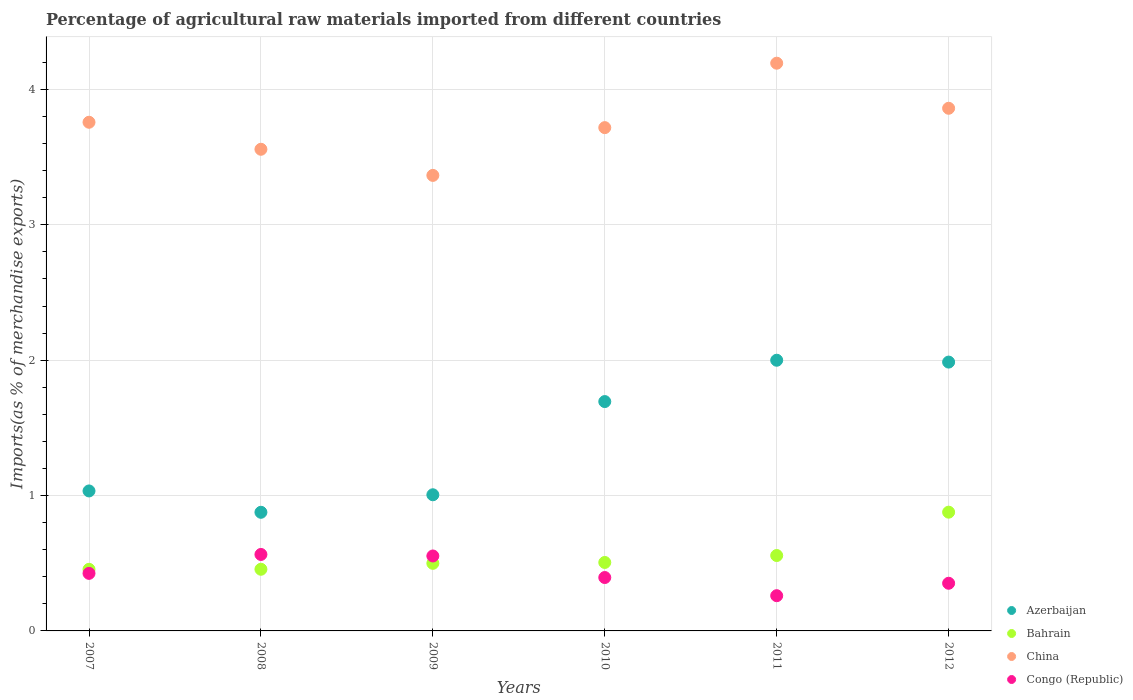What is the percentage of imports to different countries in China in 2007?
Offer a very short reply. 3.76. Across all years, what is the maximum percentage of imports to different countries in China?
Keep it short and to the point. 4.19. Across all years, what is the minimum percentage of imports to different countries in Congo (Republic)?
Your response must be concise. 0.26. What is the total percentage of imports to different countries in China in the graph?
Offer a terse response. 22.45. What is the difference between the percentage of imports to different countries in China in 2008 and that in 2012?
Provide a short and direct response. -0.3. What is the difference between the percentage of imports to different countries in China in 2007 and the percentage of imports to different countries in Congo (Republic) in 2012?
Ensure brevity in your answer.  3.41. What is the average percentage of imports to different countries in Bahrain per year?
Offer a terse response. 0.56. In the year 2012, what is the difference between the percentage of imports to different countries in Azerbaijan and percentage of imports to different countries in Congo (Republic)?
Offer a very short reply. 1.63. In how many years, is the percentage of imports to different countries in China greater than 0.4 %?
Your answer should be compact. 6. What is the ratio of the percentage of imports to different countries in Azerbaijan in 2011 to that in 2012?
Ensure brevity in your answer.  1.01. Is the percentage of imports to different countries in Bahrain in 2010 less than that in 2012?
Offer a very short reply. Yes. What is the difference between the highest and the second highest percentage of imports to different countries in Bahrain?
Offer a very short reply. 0.32. What is the difference between the highest and the lowest percentage of imports to different countries in Congo (Republic)?
Give a very brief answer. 0.3. In how many years, is the percentage of imports to different countries in Azerbaijan greater than the average percentage of imports to different countries in Azerbaijan taken over all years?
Give a very brief answer. 3. Is the sum of the percentage of imports to different countries in Congo (Republic) in 2008 and 2010 greater than the maximum percentage of imports to different countries in Bahrain across all years?
Your answer should be very brief. Yes. Is it the case that in every year, the sum of the percentage of imports to different countries in Azerbaijan and percentage of imports to different countries in Bahrain  is greater than the sum of percentage of imports to different countries in Congo (Republic) and percentage of imports to different countries in China?
Provide a succinct answer. Yes. What is the difference between two consecutive major ticks on the Y-axis?
Provide a short and direct response. 1. How are the legend labels stacked?
Provide a succinct answer. Vertical. What is the title of the graph?
Offer a very short reply. Percentage of agricultural raw materials imported from different countries. Does "Niger" appear as one of the legend labels in the graph?
Keep it short and to the point. No. What is the label or title of the X-axis?
Your answer should be very brief. Years. What is the label or title of the Y-axis?
Your answer should be compact. Imports(as % of merchandise exports). What is the Imports(as % of merchandise exports) in Azerbaijan in 2007?
Your answer should be very brief. 1.03. What is the Imports(as % of merchandise exports) in Bahrain in 2007?
Your response must be concise. 0.46. What is the Imports(as % of merchandise exports) of China in 2007?
Your answer should be very brief. 3.76. What is the Imports(as % of merchandise exports) of Congo (Republic) in 2007?
Your response must be concise. 0.43. What is the Imports(as % of merchandise exports) in Azerbaijan in 2008?
Ensure brevity in your answer.  0.88. What is the Imports(as % of merchandise exports) of Bahrain in 2008?
Keep it short and to the point. 0.46. What is the Imports(as % of merchandise exports) in China in 2008?
Give a very brief answer. 3.56. What is the Imports(as % of merchandise exports) of Congo (Republic) in 2008?
Give a very brief answer. 0.56. What is the Imports(as % of merchandise exports) of Azerbaijan in 2009?
Provide a succinct answer. 1.01. What is the Imports(as % of merchandise exports) of Bahrain in 2009?
Keep it short and to the point. 0.5. What is the Imports(as % of merchandise exports) in China in 2009?
Give a very brief answer. 3.37. What is the Imports(as % of merchandise exports) of Congo (Republic) in 2009?
Your answer should be very brief. 0.55. What is the Imports(as % of merchandise exports) of Azerbaijan in 2010?
Provide a short and direct response. 1.69. What is the Imports(as % of merchandise exports) in Bahrain in 2010?
Provide a short and direct response. 0.51. What is the Imports(as % of merchandise exports) of China in 2010?
Your response must be concise. 3.72. What is the Imports(as % of merchandise exports) of Congo (Republic) in 2010?
Your answer should be very brief. 0.39. What is the Imports(as % of merchandise exports) of Azerbaijan in 2011?
Keep it short and to the point. 2. What is the Imports(as % of merchandise exports) in Bahrain in 2011?
Make the answer very short. 0.56. What is the Imports(as % of merchandise exports) of China in 2011?
Offer a terse response. 4.19. What is the Imports(as % of merchandise exports) of Congo (Republic) in 2011?
Offer a very short reply. 0.26. What is the Imports(as % of merchandise exports) of Azerbaijan in 2012?
Provide a succinct answer. 1.99. What is the Imports(as % of merchandise exports) in Bahrain in 2012?
Your answer should be compact. 0.88. What is the Imports(as % of merchandise exports) in China in 2012?
Ensure brevity in your answer.  3.86. What is the Imports(as % of merchandise exports) of Congo (Republic) in 2012?
Offer a terse response. 0.35. Across all years, what is the maximum Imports(as % of merchandise exports) in Azerbaijan?
Offer a terse response. 2. Across all years, what is the maximum Imports(as % of merchandise exports) of Bahrain?
Provide a short and direct response. 0.88. Across all years, what is the maximum Imports(as % of merchandise exports) in China?
Keep it short and to the point. 4.19. Across all years, what is the maximum Imports(as % of merchandise exports) in Congo (Republic)?
Make the answer very short. 0.56. Across all years, what is the minimum Imports(as % of merchandise exports) of Azerbaijan?
Offer a very short reply. 0.88. Across all years, what is the minimum Imports(as % of merchandise exports) of Bahrain?
Give a very brief answer. 0.46. Across all years, what is the minimum Imports(as % of merchandise exports) of China?
Your answer should be very brief. 3.37. Across all years, what is the minimum Imports(as % of merchandise exports) in Congo (Republic)?
Provide a succinct answer. 0.26. What is the total Imports(as % of merchandise exports) of Azerbaijan in the graph?
Give a very brief answer. 8.6. What is the total Imports(as % of merchandise exports) of Bahrain in the graph?
Offer a very short reply. 3.35. What is the total Imports(as % of merchandise exports) in China in the graph?
Provide a succinct answer. 22.45. What is the total Imports(as % of merchandise exports) of Congo (Republic) in the graph?
Your answer should be compact. 2.55. What is the difference between the Imports(as % of merchandise exports) of Azerbaijan in 2007 and that in 2008?
Offer a very short reply. 0.16. What is the difference between the Imports(as % of merchandise exports) in Bahrain in 2007 and that in 2008?
Provide a short and direct response. -0. What is the difference between the Imports(as % of merchandise exports) in China in 2007 and that in 2008?
Provide a succinct answer. 0.2. What is the difference between the Imports(as % of merchandise exports) in Congo (Republic) in 2007 and that in 2008?
Offer a very short reply. -0.14. What is the difference between the Imports(as % of merchandise exports) in Azerbaijan in 2007 and that in 2009?
Your answer should be very brief. 0.03. What is the difference between the Imports(as % of merchandise exports) of Bahrain in 2007 and that in 2009?
Ensure brevity in your answer.  -0.04. What is the difference between the Imports(as % of merchandise exports) of China in 2007 and that in 2009?
Provide a short and direct response. 0.39. What is the difference between the Imports(as % of merchandise exports) of Congo (Republic) in 2007 and that in 2009?
Keep it short and to the point. -0.13. What is the difference between the Imports(as % of merchandise exports) in Azerbaijan in 2007 and that in 2010?
Keep it short and to the point. -0.66. What is the difference between the Imports(as % of merchandise exports) in Bahrain in 2007 and that in 2010?
Your answer should be very brief. -0.05. What is the difference between the Imports(as % of merchandise exports) of China in 2007 and that in 2010?
Offer a very short reply. 0.04. What is the difference between the Imports(as % of merchandise exports) of Congo (Republic) in 2007 and that in 2010?
Your response must be concise. 0.03. What is the difference between the Imports(as % of merchandise exports) of Azerbaijan in 2007 and that in 2011?
Give a very brief answer. -0.97. What is the difference between the Imports(as % of merchandise exports) of Bahrain in 2007 and that in 2011?
Offer a terse response. -0.1. What is the difference between the Imports(as % of merchandise exports) of China in 2007 and that in 2011?
Keep it short and to the point. -0.44. What is the difference between the Imports(as % of merchandise exports) in Congo (Republic) in 2007 and that in 2011?
Your response must be concise. 0.17. What is the difference between the Imports(as % of merchandise exports) in Azerbaijan in 2007 and that in 2012?
Offer a terse response. -0.95. What is the difference between the Imports(as % of merchandise exports) in Bahrain in 2007 and that in 2012?
Provide a short and direct response. -0.42. What is the difference between the Imports(as % of merchandise exports) in China in 2007 and that in 2012?
Give a very brief answer. -0.1. What is the difference between the Imports(as % of merchandise exports) in Congo (Republic) in 2007 and that in 2012?
Make the answer very short. 0.07. What is the difference between the Imports(as % of merchandise exports) in Azerbaijan in 2008 and that in 2009?
Your answer should be very brief. -0.13. What is the difference between the Imports(as % of merchandise exports) of Bahrain in 2008 and that in 2009?
Offer a terse response. -0.04. What is the difference between the Imports(as % of merchandise exports) in China in 2008 and that in 2009?
Your response must be concise. 0.19. What is the difference between the Imports(as % of merchandise exports) in Congo (Republic) in 2008 and that in 2009?
Offer a very short reply. 0.01. What is the difference between the Imports(as % of merchandise exports) of Azerbaijan in 2008 and that in 2010?
Your answer should be compact. -0.82. What is the difference between the Imports(as % of merchandise exports) in Bahrain in 2008 and that in 2010?
Offer a very short reply. -0.05. What is the difference between the Imports(as % of merchandise exports) in China in 2008 and that in 2010?
Your answer should be compact. -0.16. What is the difference between the Imports(as % of merchandise exports) of Congo (Republic) in 2008 and that in 2010?
Give a very brief answer. 0.17. What is the difference between the Imports(as % of merchandise exports) of Azerbaijan in 2008 and that in 2011?
Offer a terse response. -1.12. What is the difference between the Imports(as % of merchandise exports) in Bahrain in 2008 and that in 2011?
Provide a succinct answer. -0.1. What is the difference between the Imports(as % of merchandise exports) of China in 2008 and that in 2011?
Keep it short and to the point. -0.64. What is the difference between the Imports(as % of merchandise exports) in Congo (Republic) in 2008 and that in 2011?
Ensure brevity in your answer.  0.3. What is the difference between the Imports(as % of merchandise exports) of Azerbaijan in 2008 and that in 2012?
Provide a short and direct response. -1.11. What is the difference between the Imports(as % of merchandise exports) in Bahrain in 2008 and that in 2012?
Provide a succinct answer. -0.42. What is the difference between the Imports(as % of merchandise exports) in China in 2008 and that in 2012?
Your answer should be very brief. -0.3. What is the difference between the Imports(as % of merchandise exports) of Congo (Republic) in 2008 and that in 2012?
Give a very brief answer. 0.21. What is the difference between the Imports(as % of merchandise exports) of Azerbaijan in 2009 and that in 2010?
Your response must be concise. -0.69. What is the difference between the Imports(as % of merchandise exports) in Bahrain in 2009 and that in 2010?
Offer a terse response. -0.01. What is the difference between the Imports(as % of merchandise exports) of China in 2009 and that in 2010?
Offer a terse response. -0.35. What is the difference between the Imports(as % of merchandise exports) in Congo (Republic) in 2009 and that in 2010?
Ensure brevity in your answer.  0.16. What is the difference between the Imports(as % of merchandise exports) of Azerbaijan in 2009 and that in 2011?
Your answer should be very brief. -0.99. What is the difference between the Imports(as % of merchandise exports) of Bahrain in 2009 and that in 2011?
Ensure brevity in your answer.  -0.06. What is the difference between the Imports(as % of merchandise exports) in China in 2009 and that in 2011?
Keep it short and to the point. -0.83. What is the difference between the Imports(as % of merchandise exports) of Congo (Republic) in 2009 and that in 2011?
Your answer should be very brief. 0.29. What is the difference between the Imports(as % of merchandise exports) in Azerbaijan in 2009 and that in 2012?
Provide a short and direct response. -0.98. What is the difference between the Imports(as % of merchandise exports) in Bahrain in 2009 and that in 2012?
Give a very brief answer. -0.38. What is the difference between the Imports(as % of merchandise exports) of China in 2009 and that in 2012?
Provide a succinct answer. -0.5. What is the difference between the Imports(as % of merchandise exports) in Congo (Republic) in 2009 and that in 2012?
Offer a very short reply. 0.2. What is the difference between the Imports(as % of merchandise exports) of Azerbaijan in 2010 and that in 2011?
Ensure brevity in your answer.  -0.31. What is the difference between the Imports(as % of merchandise exports) in Bahrain in 2010 and that in 2011?
Provide a short and direct response. -0.05. What is the difference between the Imports(as % of merchandise exports) of China in 2010 and that in 2011?
Offer a very short reply. -0.48. What is the difference between the Imports(as % of merchandise exports) in Congo (Republic) in 2010 and that in 2011?
Offer a very short reply. 0.13. What is the difference between the Imports(as % of merchandise exports) in Azerbaijan in 2010 and that in 2012?
Your answer should be very brief. -0.29. What is the difference between the Imports(as % of merchandise exports) in Bahrain in 2010 and that in 2012?
Your answer should be very brief. -0.37. What is the difference between the Imports(as % of merchandise exports) in China in 2010 and that in 2012?
Give a very brief answer. -0.14. What is the difference between the Imports(as % of merchandise exports) of Congo (Republic) in 2010 and that in 2012?
Keep it short and to the point. 0.04. What is the difference between the Imports(as % of merchandise exports) in Azerbaijan in 2011 and that in 2012?
Your answer should be very brief. 0.01. What is the difference between the Imports(as % of merchandise exports) in Bahrain in 2011 and that in 2012?
Make the answer very short. -0.32. What is the difference between the Imports(as % of merchandise exports) of China in 2011 and that in 2012?
Provide a short and direct response. 0.33. What is the difference between the Imports(as % of merchandise exports) of Congo (Republic) in 2011 and that in 2012?
Provide a succinct answer. -0.09. What is the difference between the Imports(as % of merchandise exports) of Azerbaijan in 2007 and the Imports(as % of merchandise exports) of Bahrain in 2008?
Provide a succinct answer. 0.58. What is the difference between the Imports(as % of merchandise exports) of Azerbaijan in 2007 and the Imports(as % of merchandise exports) of China in 2008?
Provide a succinct answer. -2.52. What is the difference between the Imports(as % of merchandise exports) of Azerbaijan in 2007 and the Imports(as % of merchandise exports) of Congo (Republic) in 2008?
Your answer should be compact. 0.47. What is the difference between the Imports(as % of merchandise exports) in Bahrain in 2007 and the Imports(as % of merchandise exports) in China in 2008?
Provide a succinct answer. -3.1. What is the difference between the Imports(as % of merchandise exports) in Bahrain in 2007 and the Imports(as % of merchandise exports) in Congo (Republic) in 2008?
Your answer should be compact. -0.11. What is the difference between the Imports(as % of merchandise exports) in China in 2007 and the Imports(as % of merchandise exports) in Congo (Republic) in 2008?
Give a very brief answer. 3.19. What is the difference between the Imports(as % of merchandise exports) of Azerbaijan in 2007 and the Imports(as % of merchandise exports) of Bahrain in 2009?
Give a very brief answer. 0.53. What is the difference between the Imports(as % of merchandise exports) in Azerbaijan in 2007 and the Imports(as % of merchandise exports) in China in 2009?
Your response must be concise. -2.33. What is the difference between the Imports(as % of merchandise exports) in Azerbaijan in 2007 and the Imports(as % of merchandise exports) in Congo (Republic) in 2009?
Provide a succinct answer. 0.48. What is the difference between the Imports(as % of merchandise exports) of Bahrain in 2007 and the Imports(as % of merchandise exports) of China in 2009?
Make the answer very short. -2.91. What is the difference between the Imports(as % of merchandise exports) in Bahrain in 2007 and the Imports(as % of merchandise exports) in Congo (Republic) in 2009?
Keep it short and to the point. -0.1. What is the difference between the Imports(as % of merchandise exports) of China in 2007 and the Imports(as % of merchandise exports) of Congo (Republic) in 2009?
Your answer should be very brief. 3.2. What is the difference between the Imports(as % of merchandise exports) in Azerbaijan in 2007 and the Imports(as % of merchandise exports) in Bahrain in 2010?
Offer a terse response. 0.53. What is the difference between the Imports(as % of merchandise exports) of Azerbaijan in 2007 and the Imports(as % of merchandise exports) of China in 2010?
Make the answer very short. -2.68. What is the difference between the Imports(as % of merchandise exports) in Azerbaijan in 2007 and the Imports(as % of merchandise exports) in Congo (Republic) in 2010?
Your answer should be compact. 0.64. What is the difference between the Imports(as % of merchandise exports) of Bahrain in 2007 and the Imports(as % of merchandise exports) of China in 2010?
Provide a succinct answer. -3.26. What is the difference between the Imports(as % of merchandise exports) in Bahrain in 2007 and the Imports(as % of merchandise exports) in Congo (Republic) in 2010?
Offer a terse response. 0.06. What is the difference between the Imports(as % of merchandise exports) of China in 2007 and the Imports(as % of merchandise exports) of Congo (Republic) in 2010?
Provide a short and direct response. 3.36. What is the difference between the Imports(as % of merchandise exports) in Azerbaijan in 2007 and the Imports(as % of merchandise exports) in Bahrain in 2011?
Provide a succinct answer. 0.48. What is the difference between the Imports(as % of merchandise exports) of Azerbaijan in 2007 and the Imports(as % of merchandise exports) of China in 2011?
Make the answer very short. -3.16. What is the difference between the Imports(as % of merchandise exports) of Azerbaijan in 2007 and the Imports(as % of merchandise exports) of Congo (Republic) in 2011?
Your answer should be compact. 0.77. What is the difference between the Imports(as % of merchandise exports) of Bahrain in 2007 and the Imports(as % of merchandise exports) of China in 2011?
Your answer should be very brief. -3.74. What is the difference between the Imports(as % of merchandise exports) in Bahrain in 2007 and the Imports(as % of merchandise exports) in Congo (Republic) in 2011?
Make the answer very short. 0.19. What is the difference between the Imports(as % of merchandise exports) of China in 2007 and the Imports(as % of merchandise exports) of Congo (Republic) in 2011?
Provide a succinct answer. 3.5. What is the difference between the Imports(as % of merchandise exports) in Azerbaijan in 2007 and the Imports(as % of merchandise exports) in Bahrain in 2012?
Provide a succinct answer. 0.16. What is the difference between the Imports(as % of merchandise exports) in Azerbaijan in 2007 and the Imports(as % of merchandise exports) in China in 2012?
Make the answer very short. -2.83. What is the difference between the Imports(as % of merchandise exports) of Azerbaijan in 2007 and the Imports(as % of merchandise exports) of Congo (Republic) in 2012?
Your answer should be compact. 0.68. What is the difference between the Imports(as % of merchandise exports) of Bahrain in 2007 and the Imports(as % of merchandise exports) of China in 2012?
Provide a succinct answer. -3.41. What is the difference between the Imports(as % of merchandise exports) in Bahrain in 2007 and the Imports(as % of merchandise exports) in Congo (Republic) in 2012?
Provide a short and direct response. 0.1. What is the difference between the Imports(as % of merchandise exports) of China in 2007 and the Imports(as % of merchandise exports) of Congo (Republic) in 2012?
Provide a short and direct response. 3.41. What is the difference between the Imports(as % of merchandise exports) of Azerbaijan in 2008 and the Imports(as % of merchandise exports) of Bahrain in 2009?
Keep it short and to the point. 0.38. What is the difference between the Imports(as % of merchandise exports) in Azerbaijan in 2008 and the Imports(as % of merchandise exports) in China in 2009?
Keep it short and to the point. -2.49. What is the difference between the Imports(as % of merchandise exports) of Azerbaijan in 2008 and the Imports(as % of merchandise exports) of Congo (Republic) in 2009?
Provide a short and direct response. 0.32. What is the difference between the Imports(as % of merchandise exports) of Bahrain in 2008 and the Imports(as % of merchandise exports) of China in 2009?
Ensure brevity in your answer.  -2.91. What is the difference between the Imports(as % of merchandise exports) in Bahrain in 2008 and the Imports(as % of merchandise exports) in Congo (Republic) in 2009?
Your answer should be compact. -0.1. What is the difference between the Imports(as % of merchandise exports) of China in 2008 and the Imports(as % of merchandise exports) of Congo (Republic) in 2009?
Your answer should be compact. 3. What is the difference between the Imports(as % of merchandise exports) in Azerbaijan in 2008 and the Imports(as % of merchandise exports) in Bahrain in 2010?
Provide a succinct answer. 0.37. What is the difference between the Imports(as % of merchandise exports) in Azerbaijan in 2008 and the Imports(as % of merchandise exports) in China in 2010?
Offer a terse response. -2.84. What is the difference between the Imports(as % of merchandise exports) of Azerbaijan in 2008 and the Imports(as % of merchandise exports) of Congo (Republic) in 2010?
Provide a short and direct response. 0.48. What is the difference between the Imports(as % of merchandise exports) in Bahrain in 2008 and the Imports(as % of merchandise exports) in China in 2010?
Your response must be concise. -3.26. What is the difference between the Imports(as % of merchandise exports) in Bahrain in 2008 and the Imports(as % of merchandise exports) in Congo (Republic) in 2010?
Keep it short and to the point. 0.06. What is the difference between the Imports(as % of merchandise exports) of China in 2008 and the Imports(as % of merchandise exports) of Congo (Republic) in 2010?
Your answer should be compact. 3.16. What is the difference between the Imports(as % of merchandise exports) in Azerbaijan in 2008 and the Imports(as % of merchandise exports) in Bahrain in 2011?
Your answer should be very brief. 0.32. What is the difference between the Imports(as % of merchandise exports) in Azerbaijan in 2008 and the Imports(as % of merchandise exports) in China in 2011?
Keep it short and to the point. -3.32. What is the difference between the Imports(as % of merchandise exports) of Azerbaijan in 2008 and the Imports(as % of merchandise exports) of Congo (Republic) in 2011?
Offer a terse response. 0.62. What is the difference between the Imports(as % of merchandise exports) of Bahrain in 2008 and the Imports(as % of merchandise exports) of China in 2011?
Ensure brevity in your answer.  -3.74. What is the difference between the Imports(as % of merchandise exports) in Bahrain in 2008 and the Imports(as % of merchandise exports) in Congo (Republic) in 2011?
Your response must be concise. 0.2. What is the difference between the Imports(as % of merchandise exports) in China in 2008 and the Imports(as % of merchandise exports) in Congo (Republic) in 2011?
Give a very brief answer. 3.3. What is the difference between the Imports(as % of merchandise exports) in Azerbaijan in 2008 and the Imports(as % of merchandise exports) in Bahrain in 2012?
Provide a short and direct response. -0. What is the difference between the Imports(as % of merchandise exports) in Azerbaijan in 2008 and the Imports(as % of merchandise exports) in China in 2012?
Your response must be concise. -2.98. What is the difference between the Imports(as % of merchandise exports) of Azerbaijan in 2008 and the Imports(as % of merchandise exports) of Congo (Republic) in 2012?
Your answer should be compact. 0.52. What is the difference between the Imports(as % of merchandise exports) of Bahrain in 2008 and the Imports(as % of merchandise exports) of China in 2012?
Your answer should be compact. -3.41. What is the difference between the Imports(as % of merchandise exports) of Bahrain in 2008 and the Imports(as % of merchandise exports) of Congo (Republic) in 2012?
Your response must be concise. 0.1. What is the difference between the Imports(as % of merchandise exports) in China in 2008 and the Imports(as % of merchandise exports) in Congo (Republic) in 2012?
Offer a terse response. 3.21. What is the difference between the Imports(as % of merchandise exports) in Azerbaijan in 2009 and the Imports(as % of merchandise exports) in Bahrain in 2010?
Your response must be concise. 0.5. What is the difference between the Imports(as % of merchandise exports) in Azerbaijan in 2009 and the Imports(as % of merchandise exports) in China in 2010?
Ensure brevity in your answer.  -2.71. What is the difference between the Imports(as % of merchandise exports) in Azerbaijan in 2009 and the Imports(as % of merchandise exports) in Congo (Republic) in 2010?
Provide a succinct answer. 0.61. What is the difference between the Imports(as % of merchandise exports) in Bahrain in 2009 and the Imports(as % of merchandise exports) in China in 2010?
Make the answer very short. -3.22. What is the difference between the Imports(as % of merchandise exports) in Bahrain in 2009 and the Imports(as % of merchandise exports) in Congo (Republic) in 2010?
Give a very brief answer. 0.1. What is the difference between the Imports(as % of merchandise exports) of China in 2009 and the Imports(as % of merchandise exports) of Congo (Republic) in 2010?
Your answer should be compact. 2.97. What is the difference between the Imports(as % of merchandise exports) in Azerbaijan in 2009 and the Imports(as % of merchandise exports) in Bahrain in 2011?
Make the answer very short. 0.45. What is the difference between the Imports(as % of merchandise exports) of Azerbaijan in 2009 and the Imports(as % of merchandise exports) of China in 2011?
Offer a terse response. -3.19. What is the difference between the Imports(as % of merchandise exports) in Azerbaijan in 2009 and the Imports(as % of merchandise exports) in Congo (Republic) in 2011?
Offer a very short reply. 0.75. What is the difference between the Imports(as % of merchandise exports) of Bahrain in 2009 and the Imports(as % of merchandise exports) of China in 2011?
Provide a short and direct response. -3.69. What is the difference between the Imports(as % of merchandise exports) of Bahrain in 2009 and the Imports(as % of merchandise exports) of Congo (Republic) in 2011?
Your answer should be compact. 0.24. What is the difference between the Imports(as % of merchandise exports) in China in 2009 and the Imports(as % of merchandise exports) in Congo (Republic) in 2011?
Provide a short and direct response. 3.11. What is the difference between the Imports(as % of merchandise exports) in Azerbaijan in 2009 and the Imports(as % of merchandise exports) in Bahrain in 2012?
Your response must be concise. 0.13. What is the difference between the Imports(as % of merchandise exports) in Azerbaijan in 2009 and the Imports(as % of merchandise exports) in China in 2012?
Your response must be concise. -2.86. What is the difference between the Imports(as % of merchandise exports) of Azerbaijan in 2009 and the Imports(as % of merchandise exports) of Congo (Republic) in 2012?
Make the answer very short. 0.65. What is the difference between the Imports(as % of merchandise exports) in Bahrain in 2009 and the Imports(as % of merchandise exports) in China in 2012?
Make the answer very short. -3.36. What is the difference between the Imports(as % of merchandise exports) of Bahrain in 2009 and the Imports(as % of merchandise exports) of Congo (Republic) in 2012?
Give a very brief answer. 0.15. What is the difference between the Imports(as % of merchandise exports) in China in 2009 and the Imports(as % of merchandise exports) in Congo (Republic) in 2012?
Give a very brief answer. 3.01. What is the difference between the Imports(as % of merchandise exports) in Azerbaijan in 2010 and the Imports(as % of merchandise exports) in Bahrain in 2011?
Ensure brevity in your answer.  1.14. What is the difference between the Imports(as % of merchandise exports) of Azerbaijan in 2010 and the Imports(as % of merchandise exports) of China in 2011?
Offer a very short reply. -2.5. What is the difference between the Imports(as % of merchandise exports) in Azerbaijan in 2010 and the Imports(as % of merchandise exports) in Congo (Republic) in 2011?
Your answer should be compact. 1.43. What is the difference between the Imports(as % of merchandise exports) in Bahrain in 2010 and the Imports(as % of merchandise exports) in China in 2011?
Provide a short and direct response. -3.69. What is the difference between the Imports(as % of merchandise exports) of Bahrain in 2010 and the Imports(as % of merchandise exports) of Congo (Republic) in 2011?
Offer a terse response. 0.25. What is the difference between the Imports(as % of merchandise exports) of China in 2010 and the Imports(as % of merchandise exports) of Congo (Republic) in 2011?
Your response must be concise. 3.46. What is the difference between the Imports(as % of merchandise exports) in Azerbaijan in 2010 and the Imports(as % of merchandise exports) in Bahrain in 2012?
Your answer should be compact. 0.82. What is the difference between the Imports(as % of merchandise exports) in Azerbaijan in 2010 and the Imports(as % of merchandise exports) in China in 2012?
Your response must be concise. -2.17. What is the difference between the Imports(as % of merchandise exports) of Azerbaijan in 2010 and the Imports(as % of merchandise exports) of Congo (Republic) in 2012?
Give a very brief answer. 1.34. What is the difference between the Imports(as % of merchandise exports) in Bahrain in 2010 and the Imports(as % of merchandise exports) in China in 2012?
Your answer should be very brief. -3.36. What is the difference between the Imports(as % of merchandise exports) in Bahrain in 2010 and the Imports(as % of merchandise exports) in Congo (Republic) in 2012?
Keep it short and to the point. 0.15. What is the difference between the Imports(as % of merchandise exports) of China in 2010 and the Imports(as % of merchandise exports) of Congo (Republic) in 2012?
Your answer should be very brief. 3.37. What is the difference between the Imports(as % of merchandise exports) in Azerbaijan in 2011 and the Imports(as % of merchandise exports) in Bahrain in 2012?
Offer a very short reply. 1.12. What is the difference between the Imports(as % of merchandise exports) in Azerbaijan in 2011 and the Imports(as % of merchandise exports) in China in 2012?
Give a very brief answer. -1.86. What is the difference between the Imports(as % of merchandise exports) in Azerbaijan in 2011 and the Imports(as % of merchandise exports) in Congo (Republic) in 2012?
Provide a succinct answer. 1.65. What is the difference between the Imports(as % of merchandise exports) of Bahrain in 2011 and the Imports(as % of merchandise exports) of China in 2012?
Your response must be concise. -3.3. What is the difference between the Imports(as % of merchandise exports) in Bahrain in 2011 and the Imports(as % of merchandise exports) in Congo (Republic) in 2012?
Offer a very short reply. 0.2. What is the difference between the Imports(as % of merchandise exports) in China in 2011 and the Imports(as % of merchandise exports) in Congo (Republic) in 2012?
Offer a very short reply. 3.84. What is the average Imports(as % of merchandise exports) of Azerbaijan per year?
Offer a very short reply. 1.43. What is the average Imports(as % of merchandise exports) in Bahrain per year?
Ensure brevity in your answer.  0.56. What is the average Imports(as % of merchandise exports) of China per year?
Your response must be concise. 3.74. What is the average Imports(as % of merchandise exports) of Congo (Republic) per year?
Provide a succinct answer. 0.43. In the year 2007, what is the difference between the Imports(as % of merchandise exports) in Azerbaijan and Imports(as % of merchandise exports) in Bahrain?
Your answer should be compact. 0.58. In the year 2007, what is the difference between the Imports(as % of merchandise exports) of Azerbaijan and Imports(as % of merchandise exports) of China?
Ensure brevity in your answer.  -2.72. In the year 2007, what is the difference between the Imports(as % of merchandise exports) in Azerbaijan and Imports(as % of merchandise exports) in Congo (Republic)?
Make the answer very short. 0.61. In the year 2007, what is the difference between the Imports(as % of merchandise exports) in Bahrain and Imports(as % of merchandise exports) in China?
Give a very brief answer. -3.3. In the year 2007, what is the difference between the Imports(as % of merchandise exports) of Bahrain and Imports(as % of merchandise exports) of Congo (Republic)?
Provide a short and direct response. 0.03. In the year 2007, what is the difference between the Imports(as % of merchandise exports) of China and Imports(as % of merchandise exports) of Congo (Republic)?
Make the answer very short. 3.33. In the year 2008, what is the difference between the Imports(as % of merchandise exports) in Azerbaijan and Imports(as % of merchandise exports) in Bahrain?
Your answer should be compact. 0.42. In the year 2008, what is the difference between the Imports(as % of merchandise exports) of Azerbaijan and Imports(as % of merchandise exports) of China?
Your response must be concise. -2.68. In the year 2008, what is the difference between the Imports(as % of merchandise exports) in Azerbaijan and Imports(as % of merchandise exports) in Congo (Republic)?
Keep it short and to the point. 0.31. In the year 2008, what is the difference between the Imports(as % of merchandise exports) in Bahrain and Imports(as % of merchandise exports) in China?
Ensure brevity in your answer.  -3.1. In the year 2008, what is the difference between the Imports(as % of merchandise exports) in Bahrain and Imports(as % of merchandise exports) in Congo (Republic)?
Provide a succinct answer. -0.11. In the year 2008, what is the difference between the Imports(as % of merchandise exports) of China and Imports(as % of merchandise exports) of Congo (Republic)?
Offer a terse response. 2.99. In the year 2009, what is the difference between the Imports(as % of merchandise exports) of Azerbaijan and Imports(as % of merchandise exports) of Bahrain?
Keep it short and to the point. 0.51. In the year 2009, what is the difference between the Imports(as % of merchandise exports) in Azerbaijan and Imports(as % of merchandise exports) in China?
Your answer should be compact. -2.36. In the year 2009, what is the difference between the Imports(as % of merchandise exports) of Azerbaijan and Imports(as % of merchandise exports) of Congo (Republic)?
Ensure brevity in your answer.  0.45. In the year 2009, what is the difference between the Imports(as % of merchandise exports) of Bahrain and Imports(as % of merchandise exports) of China?
Your answer should be very brief. -2.87. In the year 2009, what is the difference between the Imports(as % of merchandise exports) in Bahrain and Imports(as % of merchandise exports) in Congo (Republic)?
Your response must be concise. -0.05. In the year 2009, what is the difference between the Imports(as % of merchandise exports) in China and Imports(as % of merchandise exports) in Congo (Republic)?
Offer a terse response. 2.81. In the year 2010, what is the difference between the Imports(as % of merchandise exports) in Azerbaijan and Imports(as % of merchandise exports) in Bahrain?
Give a very brief answer. 1.19. In the year 2010, what is the difference between the Imports(as % of merchandise exports) of Azerbaijan and Imports(as % of merchandise exports) of China?
Give a very brief answer. -2.02. In the year 2010, what is the difference between the Imports(as % of merchandise exports) of Azerbaijan and Imports(as % of merchandise exports) of Congo (Republic)?
Provide a succinct answer. 1.3. In the year 2010, what is the difference between the Imports(as % of merchandise exports) of Bahrain and Imports(as % of merchandise exports) of China?
Give a very brief answer. -3.21. In the year 2010, what is the difference between the Imports(as % of merchandise exports) in Bahrain and Imports(as % of merchandise exports) in Congo (Republic)?
Offer a very short reply. 0.11. In the year 2010, what is the difference between the Imports(as % of merchandise exports) of China and Imports(as % of merchandise exports) of Congo (Republic)?
Offer a very short reply. 3.32. In the year 2011, what is the difference between the Imports(as % of merchandise exports) of Azerbaijan and Imports(as % of merchandise exports) of Bahrain?
Provide a succinct answer. 1.44. In the year 2011, what is the difference between the Imports(as % of merchandise exports) of Azerbaijan and Imports(as % of merchandise exports) of China?
Your answer should be very brief. -2.19. In the year 2011, what is the difference between the Imports(as % of merchandise exports) in Azerbaijan and Imports(as % of merchandise exports) in Congo (Republic)?
Provide a succinct answer. 1.74. In the year 2011, what is the difference between the Imports(as % of merchandise exports) in Bahrain and Imports(as % of merchandise exports) in China?
Ensure brevity in your answer.  -3.64. In the year 2011, what is the difference between the Imports(as % of merchandise exports) of Bahrain and Imports(as % of merchandise exports) of Congo (Republic)?
Offer a terse response. 0.3. In the year 2011, what is the difference between the Imports(as % of merchandise exports) of China and Imports(as % of merchandise exports) of Congo (Republic)?
Provide a short and direct response. 3.93. In the year 2012, what is the difference between the Imports(as % of merchandise exports) of Azerbaijan and Imports(as % of merchandise exports) of Bahrain?
Your answer should be compact. 1.11. In the year 2012, what is the difference between the Imports(as % of merchandise exports) in Azerbaijan and Imports(as % of merchandise exports) in China?
Provide a succinct answer. -1.88. In the year 2012, what is the difference between the Imports(as % of merchandise exports) of Azerbaijan and Imports(as % of merchandise exports) of Congo (Republic)?
Your response must be concise. 1.63. In the year 2012, what is the difference between the Imports(as % of merchandise exports) in Bahrain and Imports(as % of merchandise exports) in China?
Your answer should be compact. -2.98. In the year 2012, what is the difference between the Imports(as % of merchandise exports) of Bahrain and Imports(as % of merchandise exports) of Congo (Republic)?
Ensure brevity in your answer.  0.53. In the year 2012, what is the difference between the Imports(as % of merchandise exports) of China and Imports(as % of merchandise exports) of Congo (Republic)?
Keep it short and to the point. 3.51. What is the ratio of the Imports(as % of merchandise exports) of Azerbaijan in 2007 to that in 2008?
Ensure brevity in your answer.  1.18. What is the ratio of the Imports(as % of merchandise exports) in Bahrain in 2007 to that in 2008?
Offer a terse response. 1. What is the ratio of the Imports(as % of merchandise exports) in China in 2007 to that in 2008?
Offer a terse response. 1.06. What is the ratio of the Imports(as % of merchandise exports) of Congo (Republic) in 2007 to that in 2008?
Offer a very short reply. 0.75. What is the ratio of the Imports(as % of merchandise exports) of Azerbaijan in 2007 to that in 2009?
Offer a terse response. 1.03. What is the ratio of the Imports(as % of merchandise exports) in Bahrain in 2007 to that in 2009?
Your answer should be compact. 0.91. What is the ratio of the Imports(as % of merchandise exports) in China in 2007 to that in 2009?
Keep it short and to the point. 1.12. What is the ratio of the Imports(as % of merchandise exports) in Congo (Republic) in 2007 to that in 2009?
Offer a very short reply. 0.77. What is the ratio of the Imports(as % of merchandise exports) of Azerbaijan in 2007 to that in 2010?
Your answer should be very brief. 0.61. What is the ratio of the Imports(as % of merchandise exports) in Bahrain in 2007 to that in 2010?
Provide a succinct answer. 0.9. What is the ratio of the Imports(as % of merchandise exports) of China in 2007 to that in 2010?
Give a very brief answer. 1.01. What is the ratio of the Imports(as % of merchandise exports) in Congo (Republic) in 2007 to that in 2010?
Your response must be concise. 1.08. What is the ratio of the Imports(as % of merchandise exports) of Azerbaijan in 2007 to that in 2011?
Offer a terse response. 0.52. What is the ratio of the Imports(as % of merchandise exports) of Bahrain in 2007 to that in 2011?
Give a very brief answer. 0.82. What is the ratio of the Imports(as % of merchandise exports) of China in 2007 to that in 2011?
Provide a short and direct response. 0.9. What is the ratio of the Imports(as % of merchandise exports) of Congo (Republic) in 2007 to that in 2011?
Offer a very short reply. 1.63. What is the ratio of the Imports(as % of merchandise exports) of Azerbaijan in 2007 to that in 2012?
Keep it short and to the point. 0.52. What is the ratio of the Imports(as % of merchandise exports) of Bahrain in 2007 to that in 2012?
Your answer should be very brief. 0.52. What is the ratio of the Imports(as % of merchandise exports) of China in 2007 to that in 2012?
Provide a succinct answer. 0.97. What is the ratio of the Imports(as % of merchandise exports) in Congo (Republic) in 2007 to that in 2012?
Keep it short and to the point. 1.21. What is the ratio of the Imports(as % of merchandise exports) in Azerbaijan in 2008 to that in 2009?
Give a very brief answer. 0.87. What is the ratio of the Imports(as % of merchandise exports) in Bahrain in 2008 to that in 2009?
Give a very brief answer. 0.91. What is the ratio of the Imports(as % of merchandise exports) in China in 2008 to that in 2009?
Your answer should be very brief. 1.06. What is the ratio of the Imports(as % of merchandise exports) in Congo (Republic) in 2008 to that in 2009?
Provide a short and direct response. 1.02. What is the ratio of the Imports(as % of merchandise exports) of Azerbaijan in 2008 to that in 2010?
Your answer should be very brief. 0.52. What is the ratio of the Imports(as % of merchandise exports) of Bahrain in 2008 to that in 2010?
Your response must be concise. 0.9. What is the ratio of the Imports(as % of merchandise exports) of China in 2008 to that in 2010?
Your answer should be compact. 0.96. What is the ratio of the Imports(as % of merchandise exports) in Congo (Republic) in 2008 to that in 2010?
Offer a terse response. 1.43. What is the ratio of the Imports(as % of merchandise exports) of Azerbaijan in 2008 to that in 2011?
Make the answer very short. 0.44. What is the ratio of the Imports(as % of merchandise exports) in Bahrain in 2008 to that in 2011?
Your response must be concise. 0.82. What is the ratio of the Imports(as % of merchandise exports) of China in 2008 to that in 2011?
Give a very brief answer. 0.85. What is the ratio of the Imports(as % of merchandise exports) in Congo (Republic) in 2008 to that in 2011?
Your answer should be very brief. 2.17. What is the ratio of the Imports(as % of merchandise exports) of Azerbaijan in 2008 to that in 2012?
Give a very brief answer. 0.44. What is the ratio of the Imports(as % of merchandise exports) in Bahrain in 2008 to that in 2012?
Your answer should be compact. 0.52. What is the ratio of the Imports(as % of merchandise exports) of China in 2008 to that in 2012?
Your answer should be very brief. 0.92. What is the ratio of the Imports(as % of merchandise exports) in Congo (Republic) in 2008 to that in 2012?
Offer a very short reply. 1.6. What is the ratio of the Imports(as % of merchandise exports) of Azerbaijan in 2009 to that in 2010?
Offer a terse response. 0.59. What is the ratio of the Imports(as % of merchandise exports) in Bahrain in 2009 to that in 2010?
Make the answer very short. 0.99. What is the ratio of the Imports(as % of merchandise exports) in China in 2009 to that in 2010?
Offer a very short reply. 0.91. What is the ratio of the Imports(as % of merchandise exports) of Congo (Republic) in 2009 to that in 2010?
Offer a very short reply. 1.4. What is the ratio of the Imports(as % of merchandise exports) in Azerbaijan in 2009 to that in 2011?
Keep it short and to the point. 0.5. What is the ratio of the Imports(as % of merchandise exports) in Bahrain in 2009 to that in 2011?
Offer a very short reply. 0.9. What is the ratio of the Imports(as % of merchandise exports) of China in 2009 to that in 2011?
Keep it short and to the point. 0.8. What is the ratio of the Imports(as % of merchandise exports) of Congo (Republic) in 2009 to that in 2011?
Provide a succinct answer. 2.13. What is the ratio of the Imports(as % of merchandise exports) of Azerbaijan in 2009 to that in 2012?
Make the answer very short. 0.51. What is the ratio of the Imports(as % of merchandise exports) of Bahrain in 2009 to that in 2012?
Ensure brevity in your answer.  0.57. What is the ratio of the Imports(as % of merchandise exports) in China in 2009 to that in 2012?
Give a very brief answer. 0.87. What is the ratio of the Imports(as % of merchandise exports) of Congo (Republic) in 2009 to that in 2012?
Give a very brief answer. 1.57. What is the ratio of the Imports(as % of merchandise exports) of Azerbaijan in 2010 to that in 2011?
Ensure brevity in your answer.  0.85. What is the ratio of the Imports(as % of merchandise exports) in Bahrain in 2010 to that in 2011?
Give a very brief answer. 0.91. What is the ratio of the Imports(as % of merchandise exports) in China in 2010 to that in 2011?
Ensure brevity in your answer.  0.89. What is the ratio of the Imports(as % of merchandise exports) of Congo (Republic) in 2010 to that in 2011?
Make the answer very short. 1.52. What is the ratio of the Imports(as % of merchandise exports) in Azerbaijan in 2010 to that in 2012?
Keep it short and to the point. 0.85. What is the ratio of the Imports(as % of merchandise exports) of Bahrain in 2010 to that in 2012?
Provide a succinct answer. 0.58. What is the ratio of the Imports(as % of merchandise exports) of Congo (Republic) in 2010 to that in 2012?
Offer a very short reply. 1.12. What is the ratio of the Imports(as % of merchandise exports) in Bahrain in 2011 to that in 2012?
Provide a short and direct response. 0.64. What is the ratio of the Imports(as % of merchandise exports) of China in 2011 to that in 2012?
Make the answer very short. 1.09. What is the ratio of the Imports(as % of merchandise exports) of Congo (Republic) in 2011 to that in 2012?
Keep it short and to the point. 0.74. What is the difference between the highest and the second highest Imports(as % of merchandise exports) in Azerbaijan?
Your response must be concise. 0.01. What is the difference between the highest and the second highest Imports(as % of merchandise exports) in Bahrain?
Give a very brief answer. 0.32. What is the difference between the highest and the second highest Imports(as % of merchandise exports) in China?
Keep it short and to the point. 0.33. What is the difference between the highest and the second highest Imports(as % of merchandise exports) in Congo (Republic)?
Ensure brevity in your answer.  0.01. What is the difference between the highest and the lowest Imports(as % of merchandise exports) of Azerbaijan?
Ensure brevity in your answer.  1.12. What is the difference between the highest and the lowest Imports(as % of merchandise exports) in Bahrain?
Keep it short and to the point. 0.42. What is the difference between the highest and the lowest Imports(as % of merchandise exports) of China?
Your response must be concise. 0.83. What is the difference between the highest and the lowest Imports(as % of merchandise exports) in Congo (Republic)?
Your answer should be very brief. 0.3. 